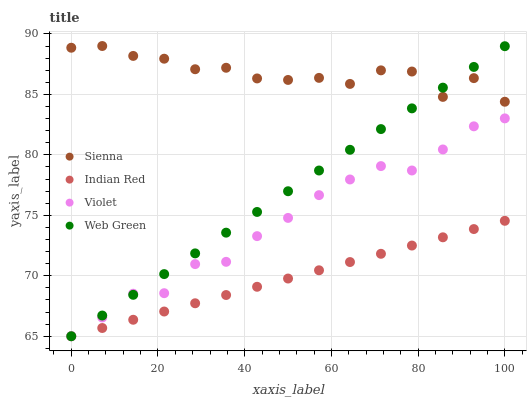Does Indian Red have the minimum area under the curve?
Answer yes or no. Yes. Does Sienna have the maximum area under the curve?
Answer yes or no. Yes. Does Web Green have the minimum area under the curve?
Answer yes or no. No. Does Web Green have the maximum area under the curve?
Answer yes or no. No. Is Indian Red the smoothest?
Answer yes or no. Yes. Is Sienna the roughest?
Answer yes or no. Yes. Is Web Green the smoothest?
Answer yes or no. No. Is Web Green the roughest?
Answer yes or no. No. Does Web Green have the lowest value?
Answer yes or no. Yes. Does Sienna have the highest value?
Answer yes or no. Yes. Does Web Green have the highest value?
Answer yes or no. No. Is Violet less than Sienna?
Answer yes or no. Yes. Is Sienna greater than Violet?
Answer yes or no. Yes. Does Web Green intersect Indian Red?
Answer yes or no. Yes. Is Web Green less than Indian Red?
Answer yes or no. No. Is Web Green greater than Indian Red?
Answer yes or no. No. Does Violet intersect Sienna?
Answer yes or no. No. 